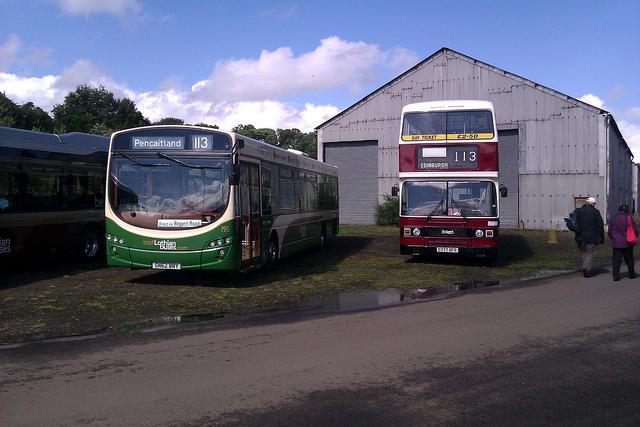Are these buses?
Give a very brief answer. Yes. Is this a clean looking double Decker bus?
Answer briefly. Yes. Are they all double deckers?
Keep it brief. No. What modes of transportation are in the photo?
Write a very short answer. Bus. How many buses are there?
Give a very brief answer. 2. 